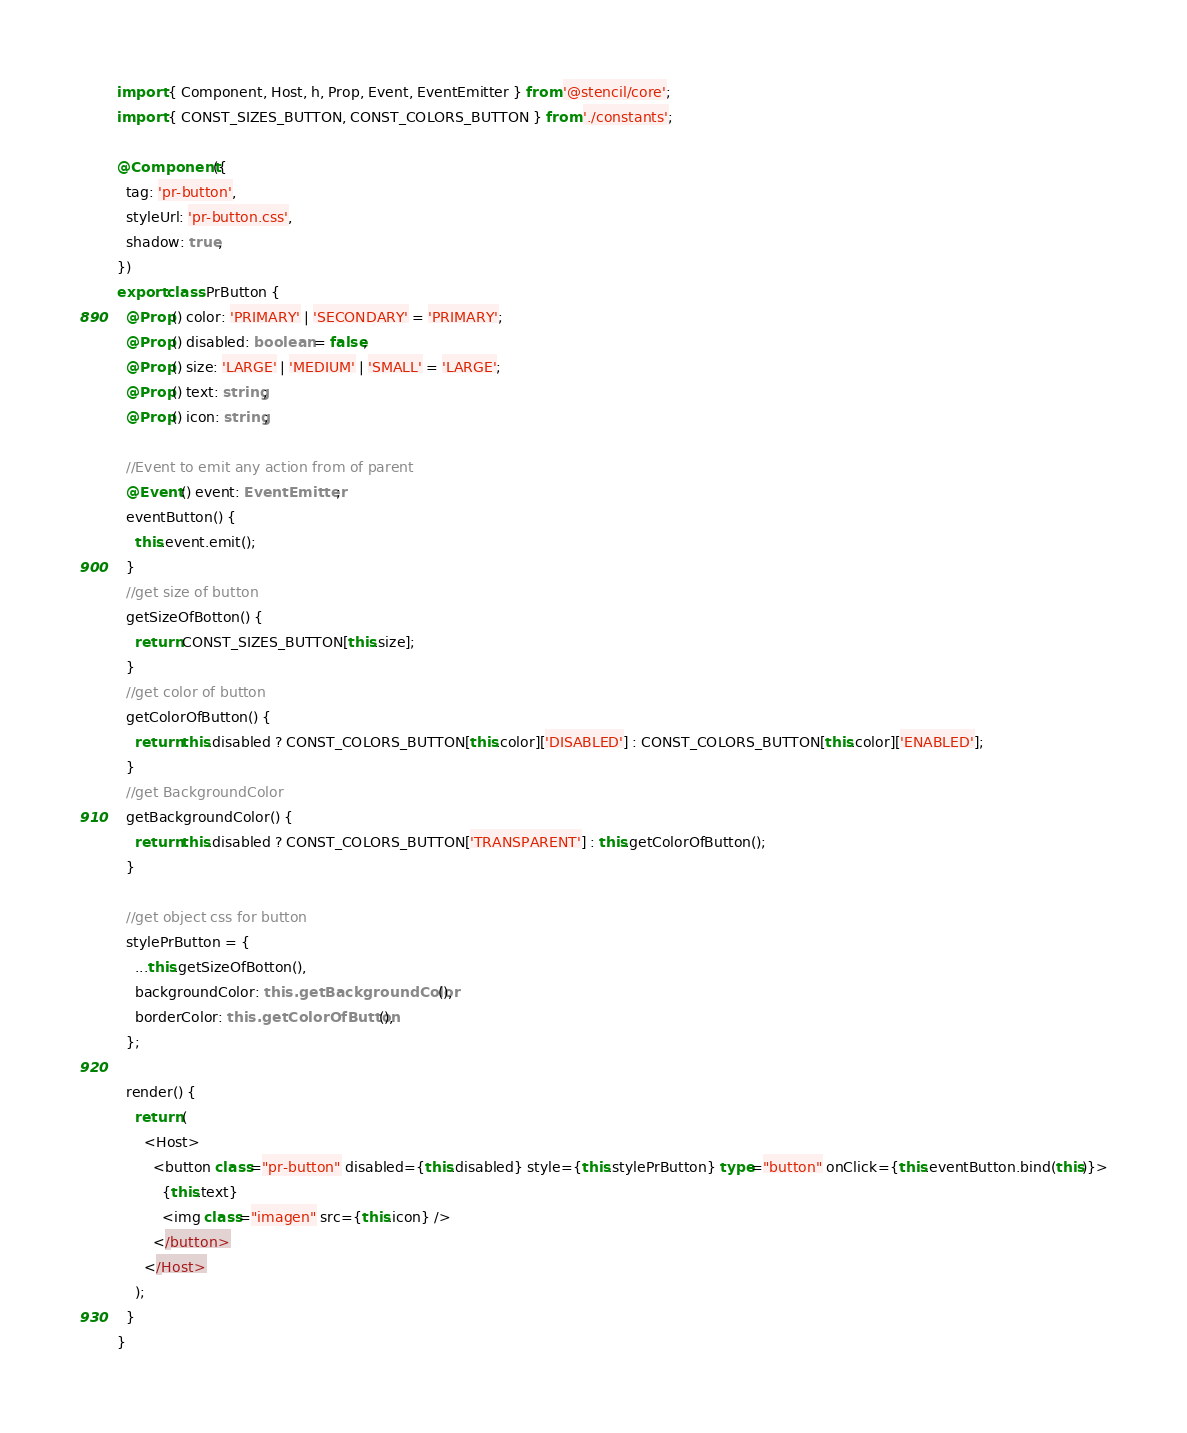<code> <loc_0><loc_0><loc_500><loc_500><_TypeScript_>import { Component, Host, h, Prop, Event, EventEmitter } from '@stencil/core';
import { CONST_SIZES_BUTTON, CONST_COLORS_BUTTON } from './constants';

@Component({
  tag: 'pr-button',
  styleUrl: 'pr-button.css',
  shadow: true,
})
export class PrButton {
  @Prop() color: 'PRIMARY' | 'SECONDARY' = 'PRIMARY';
  @Prop() disabled: boolean = false;
  @Prop() size: 'LARGE' | 'MEDIUM' | 'SMALL' = 'LARGE';
  @Prop() text: string;
  @Prop() icon: string;

  //Event to emit any action from of parent
  @Event() event: EventEmitter;
  eventButton() {
    this.event.emit();
  }
  //get size of button
  getSizeOfBotton() {
    return CONST_SIZES_BUTTON[this.size];
  }
  //get color of button
  getColorOfButton() {
    return this.disabled ? CONST_COLORS_BUTTON[this.color]['DISABLED'] : CONST_COLORS_BUTTON[this.color]['ENABLED'];
  }
  //get BackgroundColor
  getBackgroundColor() {
    return this.disabled ? CONST_COLORS_BUTTON['TRANSPARENT'] : this.getColorOfButton();
  }

  //get object css for button
  stylePrButton = {
    ...this.getSizeOfBotton(),
    backgroundColor: this.getBackgroundColor(),
    borderColor: this.getColorOfButton(),
  };

  render() {
    return (
      <Host>
        <button class="pr-button" disabled={this.disabled} style={this.stylePrButton} type="button" onClick={this.eventButton.bind(this)}>
          {this.text}
          <img class="imagen" src={this.icon} />
        </button>
      </Host>
    );
  }
}
</code> 